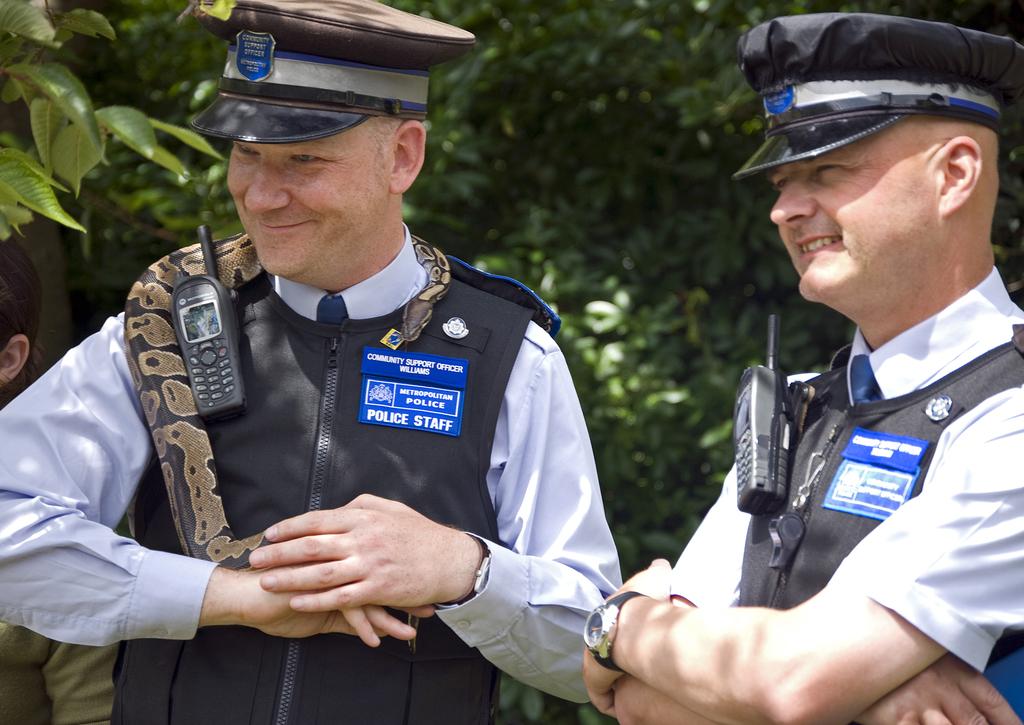What type of staff are shown here?
Offer a terse response. Police. What is the name of the officer on the left?
Your response must be concise. Williams. 